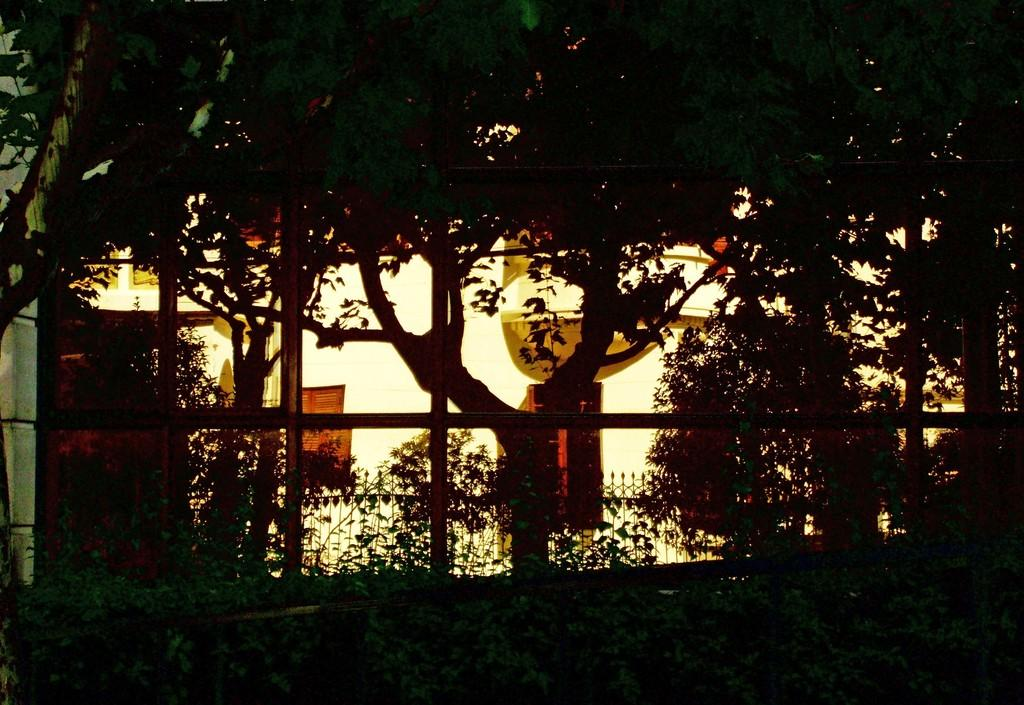What type of vegetation can be seen in the image? There are plants and trees in the image. What is the purpose of the fence in the image? The purpose of the fence in the image is not explicitly stated, but it could be to mark a boundary or provide a barrier. What can be seen in the background of the image? There is a building in the background of the image. Can you see any fangs on the plants in the image? There are no fangs present on the plants in the image, as plants do not have fangs. 